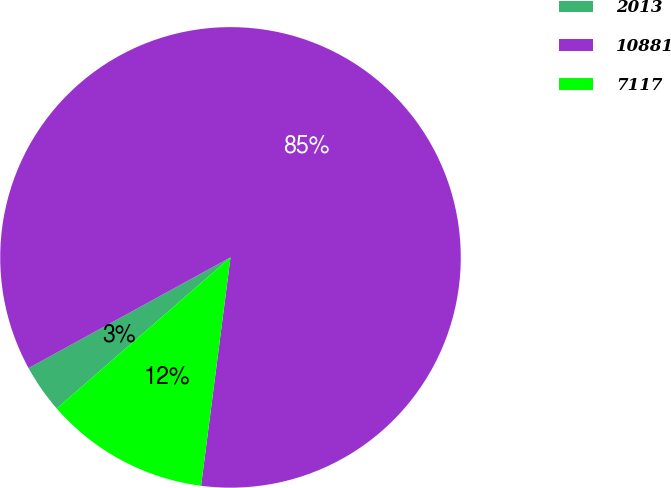<chart> <loc_0><loc_0><loc_500><loc_500><pie_chart><fcel>2013<fcel>10881<fcel>7117<nl><fcel>3.41%<fcel>85.03%<fcel>11.57%<nl></chart> 